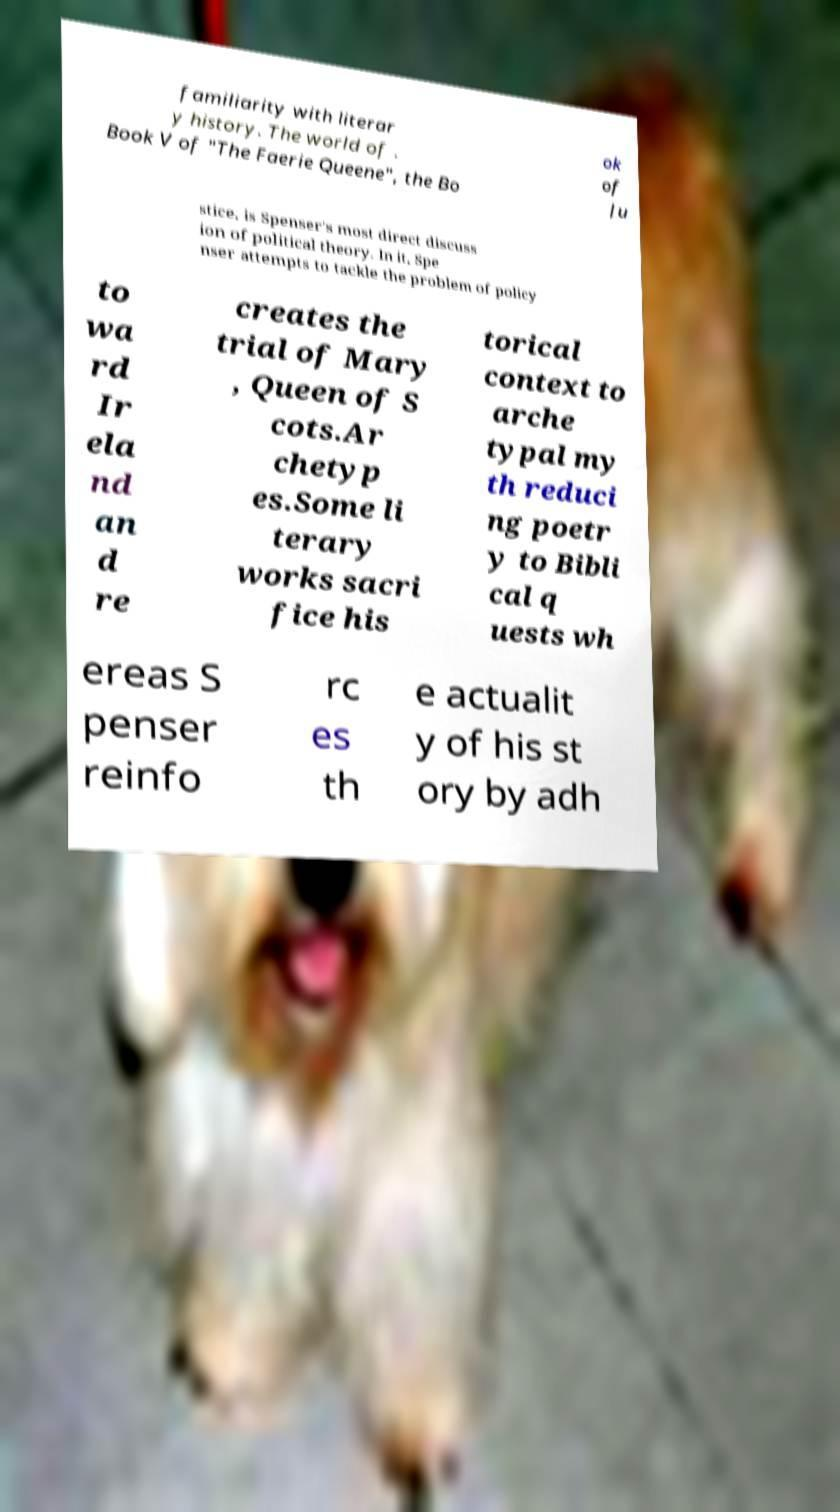What messages or text are displayed in this image? I need them in a readable, typed format. familiarity with literar y history. The world of . Book V of "The Faerie Queene", the Bo ok of Ju stice, is Spenser's most direct discuss ion of political theory. In it, Spe nser attempts to tackle the problem of policy to wa rd Ir ela nd an d re creates the trial of Mary , Queen of S cots.Ar chetyp es.Some li terary works sacri fice his torical context to arche typal my th reduci ng poetr y to Bibli cal q uests wh ereas S penser reinfo rc es th e actualit y of his st ory by adh 